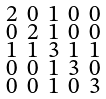<formula> <loc_0><loc_0><loc_500><loc_500>\begin{smallmatrix} 2 & 0 & 1 & 0 & 0 \\ 0 & 2 & 1 & 0 & 0 \\ 1 & 1 & 3 & 1 & 1 \\ 0 & 0 & 1 & 3 & 0 \\ 0 & 0 & 1 & 0 & 3 \end{smallmatrix}</formula> 